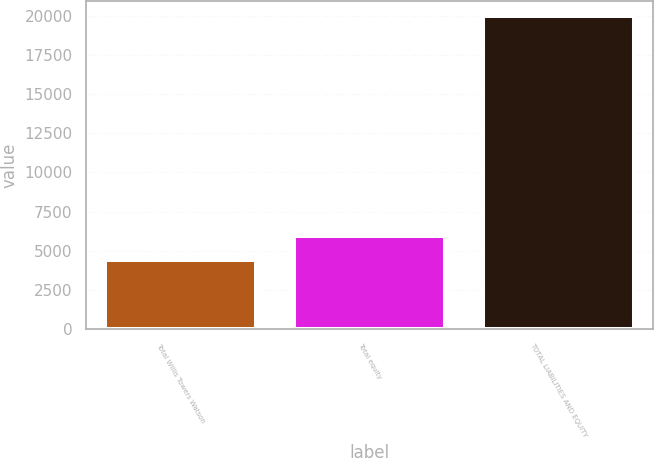Convert chart to OTSL. <chart><loc_0><loc_0><loc_500><loc_500><bar_chart><fcel>Total Willis Towers Watson<fcel>Total equity<fcel>TOTAL LIABILITIES AND EQUITY<nl><fcel>4422<fcel>5975.5<fcel>19957<nl></chart> 